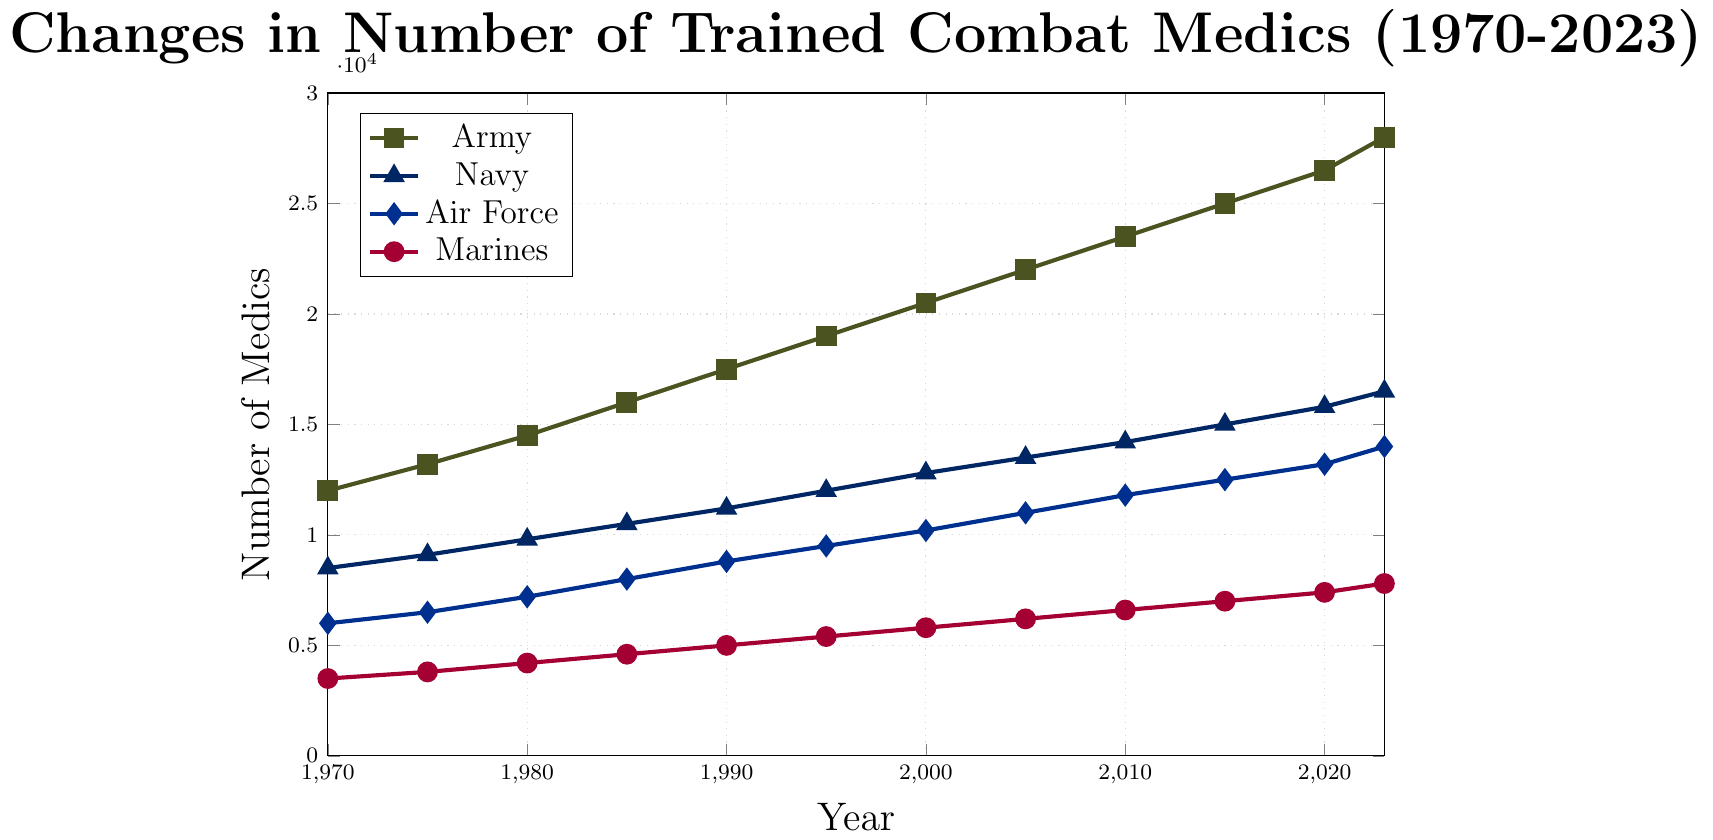What branch had the highest number of trained combat medics in 1970? By looking at the figure, we can see that the Army had the highest number of trained combat medics in 1970 at 12,000.
Answer: Army Which branch had the greatest increase in the number of trained combat medics from 1970 to 2023? By comparing the increase in numbers from 1970 to 2023 for each branch, the Army had the highest increase, going from 12,000 to 28,000, which is an increase of 16,000.
Answer: Army What is the difference in the number of combat medics between the Air Force and the Marines in 2023? In 2023, the Air Force had 14,000 medics, while the Marines had 7,800 medics. The difference is 14,000 - 7,800 = 6,200.
Answer: 6,200 Which year had the greatest number of trained combat medics across all branches combined? To determine the year with the greatest combined number, sum the medics from all branches for each year. The year 2023 has the highest total with 76,300 (28,000 Army + 16,500 Navy + 14,000 Air Force + 7,800 Marines).
Answer: 2023 How did the number of trained combat medics in the Navy change between 1985 and 2005? The Navy had 10,500 medics in 1985 and 13,500 in 2005. The change is 13,500 - 10,500 = 3,000.
Answer: 3,000 Compare the growth rate of the number of medics in the Army and the Air Force from 2000 to 2010. The Army grew from 20,500 to 23,500, a difference of 3,000. The Air Force grew from 10,200 to 11,800, a difference of 1,600. The growth rate for the Army is (3,000/20,500)*100 ≈ 14.63%, while for the Air Force it is (1,600/10,200)*100 ≈ 15.69%.
Answer: The Air Force had a higher growth rate What was the total number of trained combat medics in 1990 across all branches? Sum the numbers of trained combat medics in 1990: 17,500 (Army) + 11,200 (Navy) + 8,800 (Air Force) + 5,000 (Marines) = 42,500.
Answer: 42,500 Between which consecutive years did the Marines experience the highest increase in trained combat medics? By examining the figure, the highest increase occurred between 2015 and 2020, from 7,000 to 7,400, an increase of 400.
Answer: 2015 to 2020 